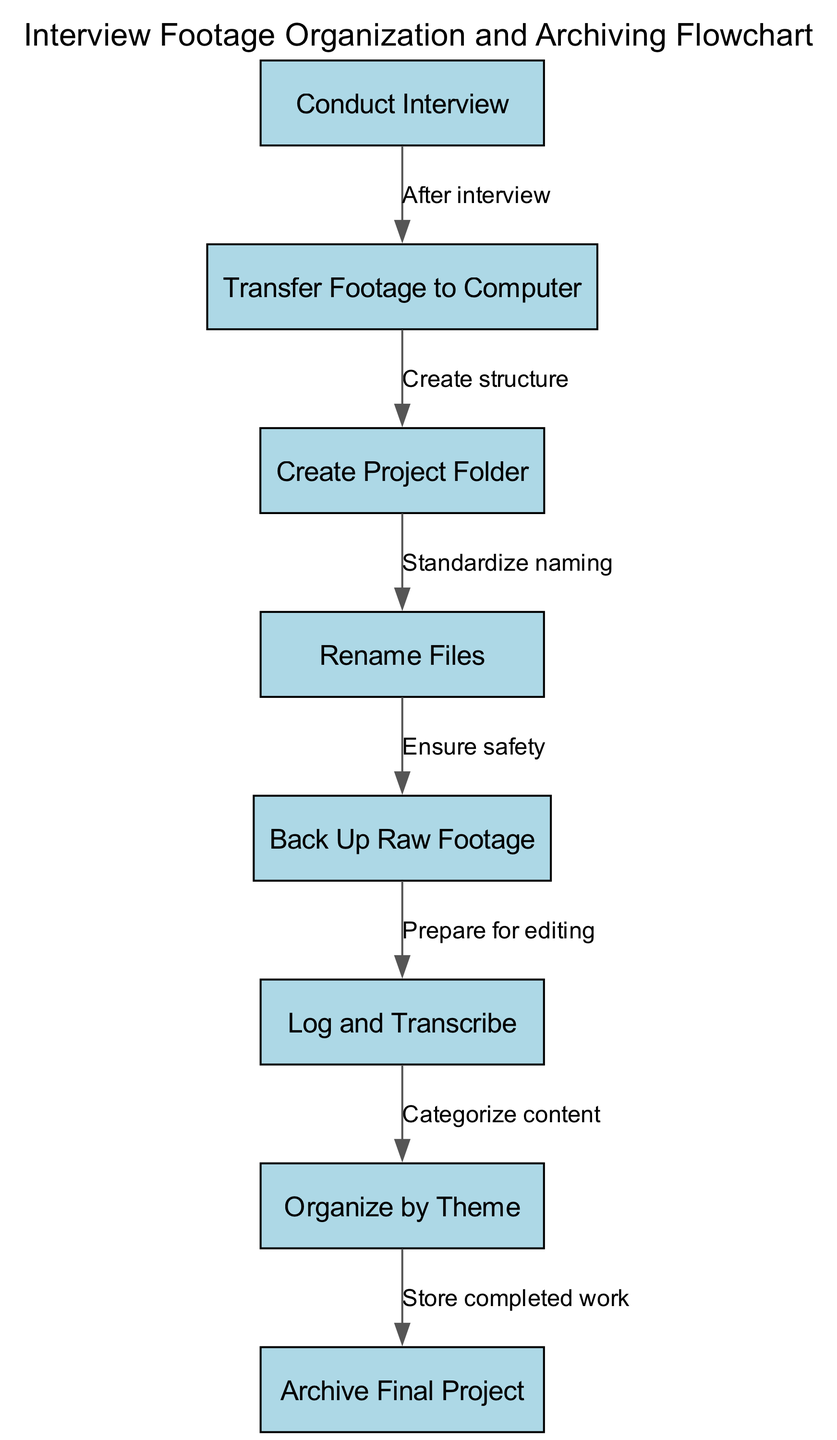What is the first step in the flowchart? The diagram shows that "Conduct Interview" is the first node, which indicates it is the starting point of the process for organizing and archiving interview footage.
Answer: Conduct Interview How many nodes are present in the flowchart? By counting the individual nodes listed in the diagram, there are a total of eight nodes that represent distinct steps in the process.
Answer: Eight What step follows "Transfer Footage to Computer"? Referring to the edges connecting the nodes, after "Transfer Footage to Computer", the next step is "Create Project Folder," as indicated by the connecting edge.
Answer: Create Project Folder What is the relationship between "Rename Files" and "Back Up Raw Footage"? The edge indicates that "Rename Files" leads to "Back Up Raw Footage," meaning that after files are renamed, the next action is to ensure safety by backing up the raw footage.
Answer: Leads to What is the final step in the archiving process? The last node in the flowchart is "Archive Final Project," which signifies that this is the ultimate action taken after all previous steps are completed.
Answer: Archive Final Project How does "Log and Transcribe" relate to "Organize by Theme"? The diagram shows that "Log and Transcribe" is a prerequisite for "Organize by Theme," indicating that categorizing content requires that logging and transcription has already been completed.
Answer: Precedes What is the purpose of creating a project folder? The text on the edge indicates that creating a project folder is meant to "Create structure," providing organization for the interview footage before further processing occurs.
Answer: Create structure What step ensures the footage is ready for editing? The edge from "Back Up Raw Footage" to "Log and Transcribe" indicates that backing up the footage prepares it for the editing phase, with logging and transcription being the necessary steps.
Answer: Prepare for editing 